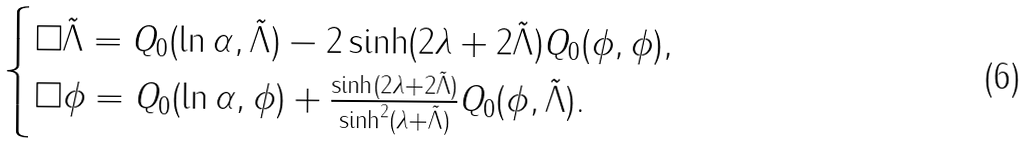Convert formula to latex. <formula><loc_0><loc_0><loc_500><loc_500>\begin{cases} \square \tilde { \Lambda } = Q _ { 0 } ( \ln \alpha , \tilde { \Lambda } ) - 2 \sinh ( 2 \lambda + 2 \tilde { \Lambda } ) Q _ { 0 } ( \phi , \phi ) , \\ \square \phi = Q _ { 0 } ( \ln \alpha , \phi ) + \frac { \sinh ( 2 \lambda + 2 \tilde { \Lambda } ) } { \sinh ^ { 2 } ( \lambda + \tilde { \Lambda } ) } Q _ { 0 } ( \phi , \tilde { \Lambda } ) . \end{cases}</formula> 